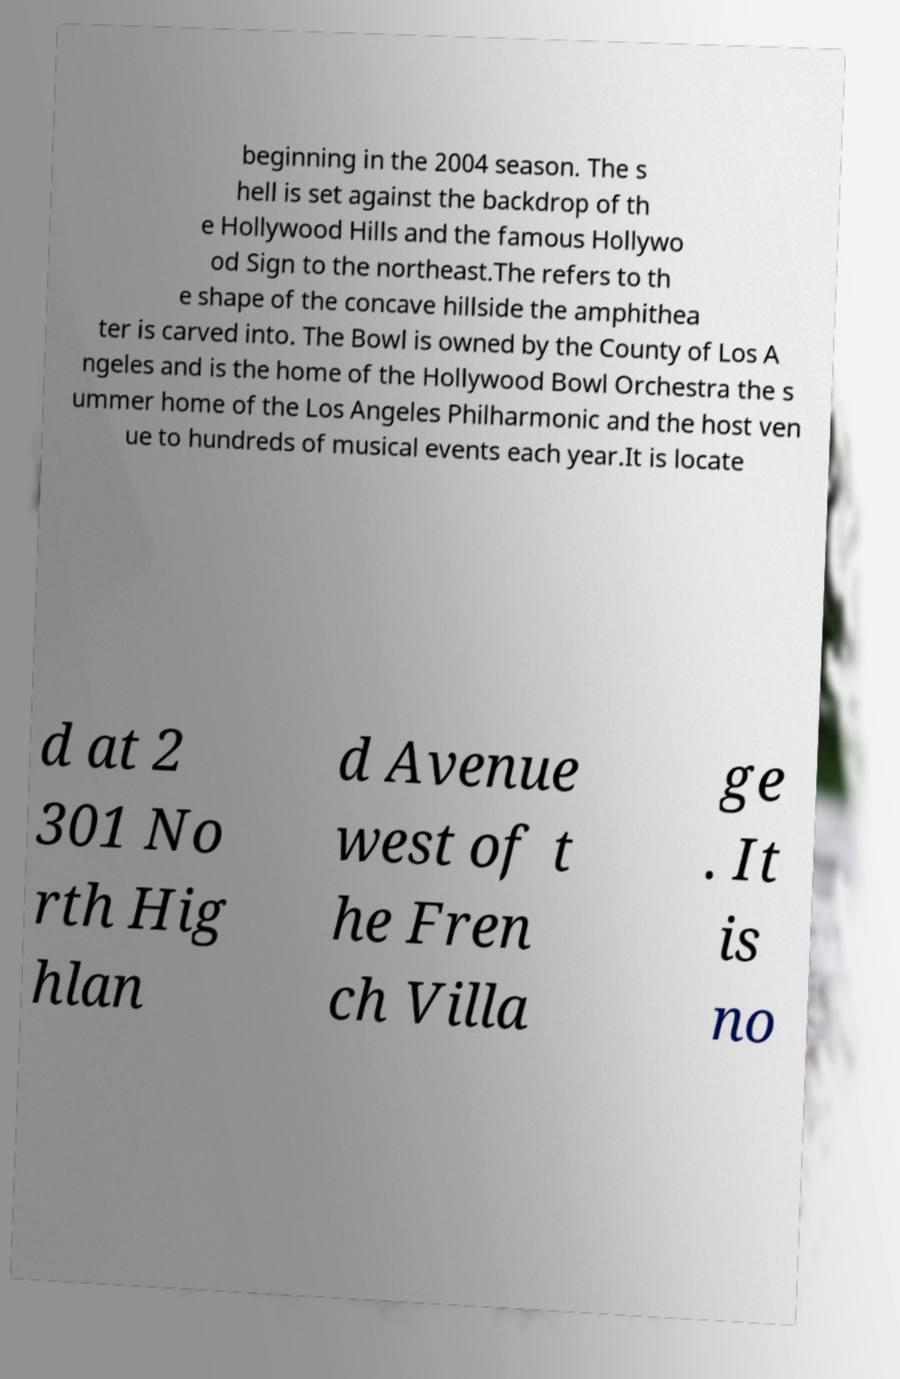Can you accurately transcribe the text from the provided image for me? beginning in the 2004 season. The s hell is set against the backdrop of th e Hollywood Hills and the famous Hollywo od Sign to the northeast.The refers to th e shape of the concave hillside the amphithea ter is carved into. The Bowl is owned by the County of Los A ngeles and is the home of the Hollywood Bowl Orchestra the s ummer home of the Los Angeles Philharmonic and the host ven ue to hundreds of musical events each year.It is locate d at 2 301 No rth Hig hlan d Avenue west of t he Fren ch Villa ge . It is no 